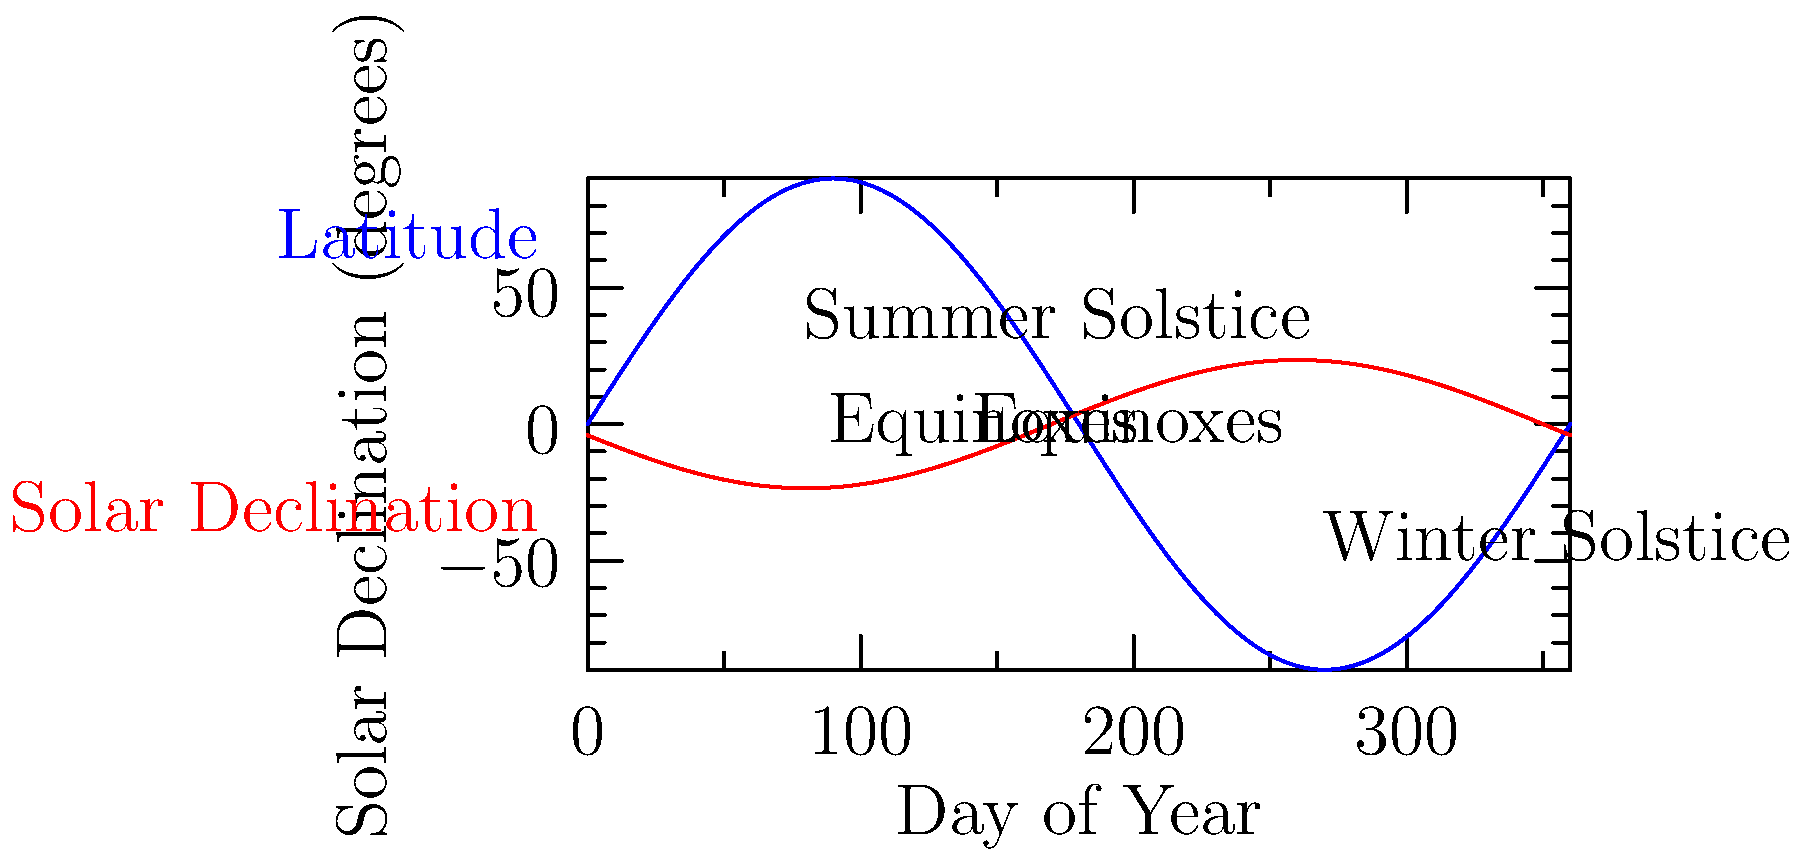As a national park ranger, you're often asked about the best times for landscape photography. Using the graph showing the relationship between latitude and solar declination throughout the year, explain how you would determine the golden hour timing for a visitor planning to photograph the park's landscapes at 45°N latitude during the summer solstice. To determine the golden hour timing for optimal landscape photography at 45°N latitude during the summer solstice, we need to follow these steps:

1. Identify the summer solstice on the graph, which occurs around day 172 of the year.

2. At the summer solstice, the solar declination (red line) reaches its maximum value of 23.5°.

3. The blue line represents the latitude (45°N in this case), which remains constant throughout the year.

4. The difference between the latitude and solar declination gives us the angle of the sun above the horizon at solar noon:
   $\text{Noon Sun Angle} = 90° - (\text{Latitude} - \text{Solar Declination})$
   $\text{Noon Sun Angle} = 90° - (45° - 23.5°) = 68.5°$

5. The golden hour typically occurs when the sun is between 6° and 10° above the horizon. To find this time, we need to calculate the number of hours from solar noon:
   $\cos(\text{Hour Angle}) = \frac{\sin(\text{Desired Elevation}) - \sin(\text{Latitude})\sin(\text{Declination})}{\cos(\text{Latitude})\cos(\text{Declination})}$

6. Using 6° as our desired elevation:
   $\cos(\text{Hour Angle}) = \frac{\sin(6°) - \sin(45°)\sin(23.5°)}{\cos(45°)\cos(23.5°)} \approx 0.1858$

7. Taking the inverse cosine and converting to hours:
   $\text{Hour Angle} = \arccos(0.1858) \approx 79.3°$
   $\text{Time from solar noon} = 79.3° \times \frac{24 \text{ hours}}{360°} \approx 5.29 \text{ hours}$

8. Therefore, the evening golden hour would start approximately 5.29 hours after solar noon, or about 5 hours and 17 minutes before sunset.

9. The morning golden hour would occur at the same time before solar noon, or about 5 hours and 17 minutes after sunrise.

As a park ranger, you could advise visitors that during the summer solstice at this latitude, they should plan their landscape photography sessions for about 5 hours and 15 minutes after sunrise or before sunset to capture the golden hour light.
Answer: 5 hours 17 minutes before sunset or after sunrise 